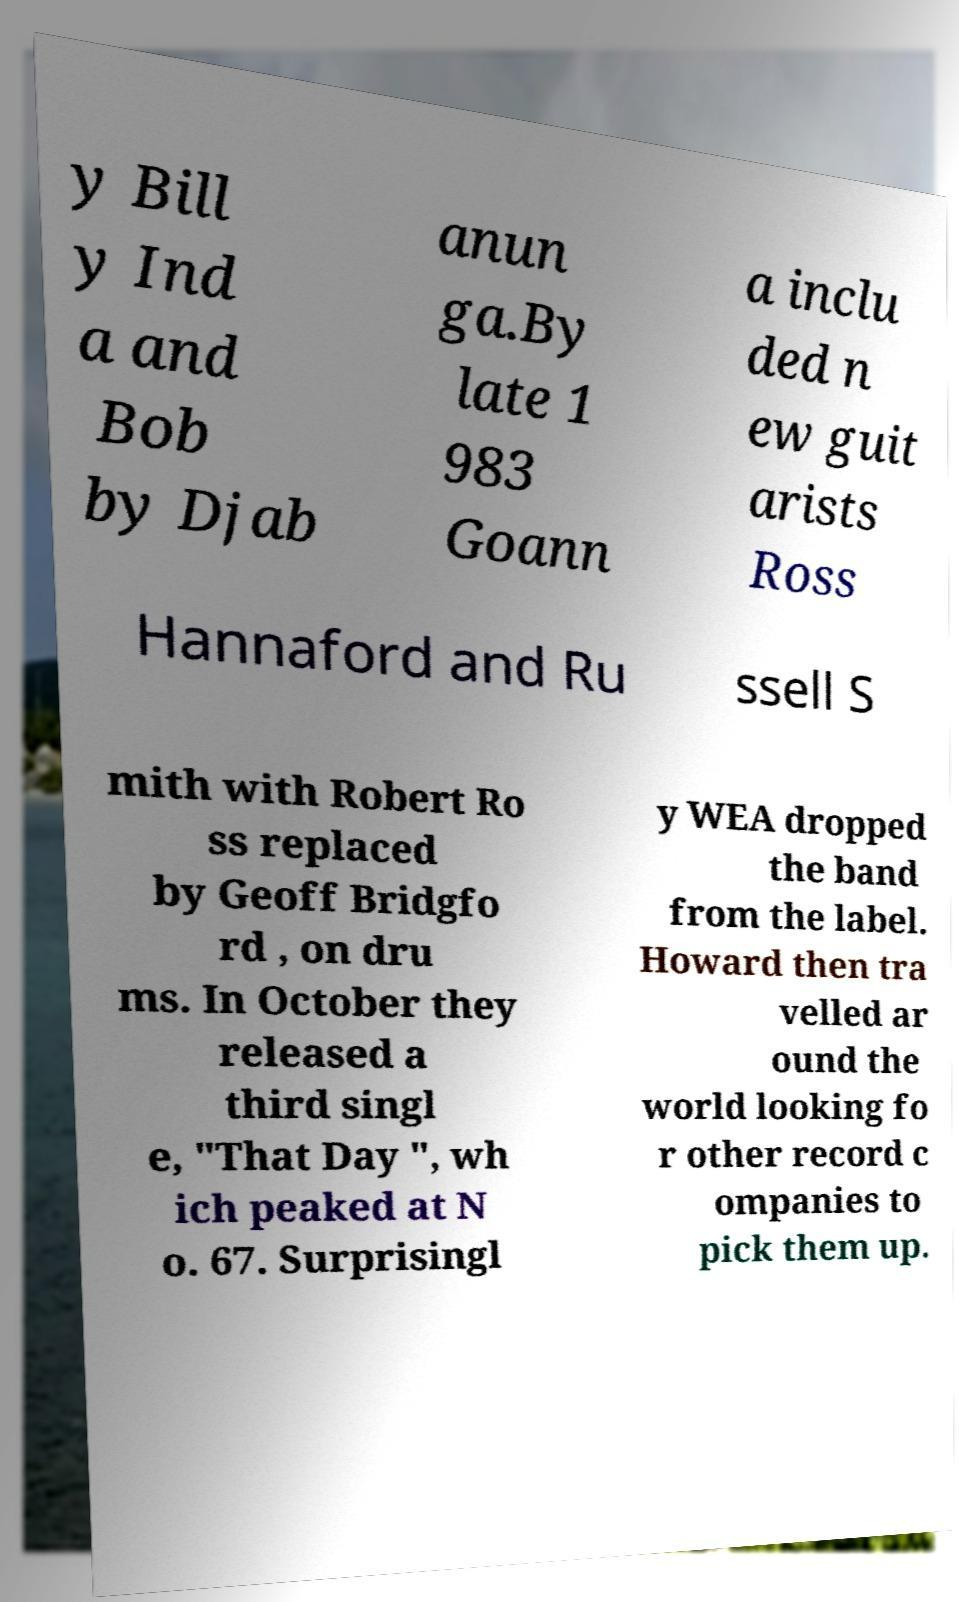Can you read and provide the text displayed in the image?This photo seems to have some interesting text. Can you extract and type it out for me? y Bill y Ind a and Bob by Djab anun ga.By late 1 983 Goann a inclu ded n ew guit arists Ross Hannaford and Ru ssell S mith with Robert Ro ss replaced by Geoff Bridgfo rd , on dru ms. In October they released a third singl e, "That Day ", wh ich peaked at N o. 67. Surprisingl y WEA dropped the band from the label. Howard then tra velled ar ound the world looking fo r other record c ompanies to pick them up. 